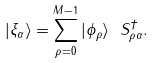Convert formula to latex. <formula><loc_0><loc_0><loc_500><loc_500>| \xi _ { \alpha } \rangle = \sum _ { \rho = 0 } ^ { M - 1 } | \phi _ { \rho } \rangle \ S ^ { \dagger } _ { \rho \alpha } .</formula> 